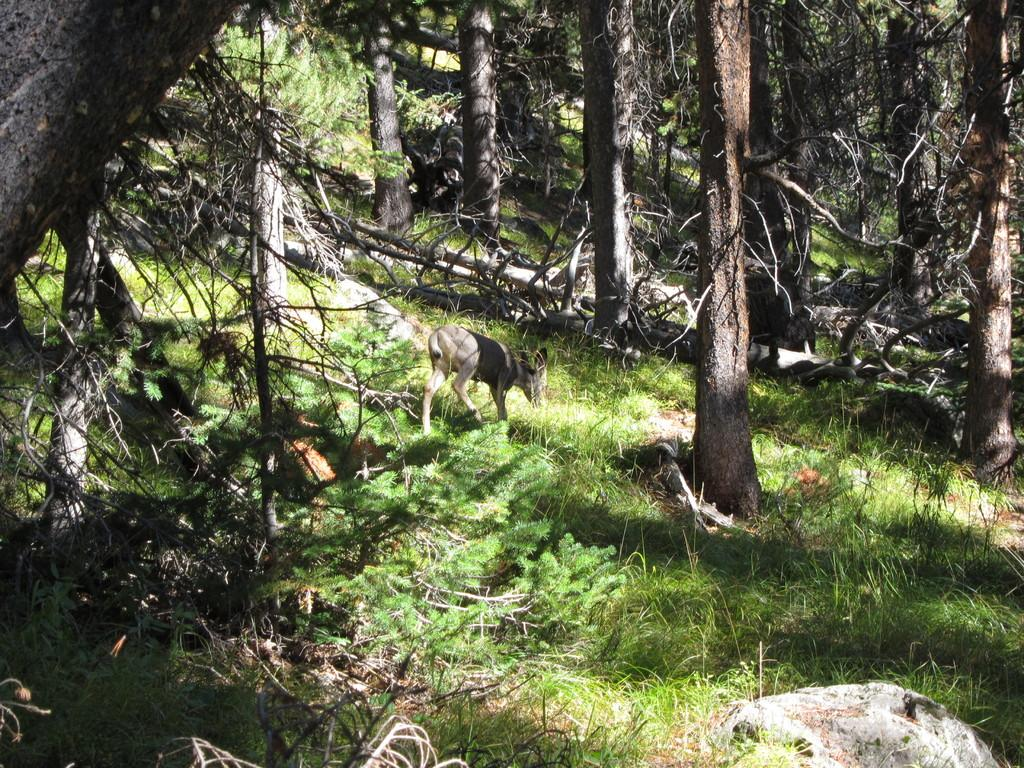What type of surface is visible in the image? There is ground visible in the image. What type of vegetation is present on the ground? There is grass on the ground. What other object can be seen on the ground? There is a rock in the image. What type of natural feature is present in the image? There are trees in the image. What is the animal standing on in the image? The animal is standing on the ground. What type of furniture is present in the image? There is no furniture present in the image. What type of doll can be seen sitting on the rock in the image? There is no doll present in the image; only an animal is mentioned. 